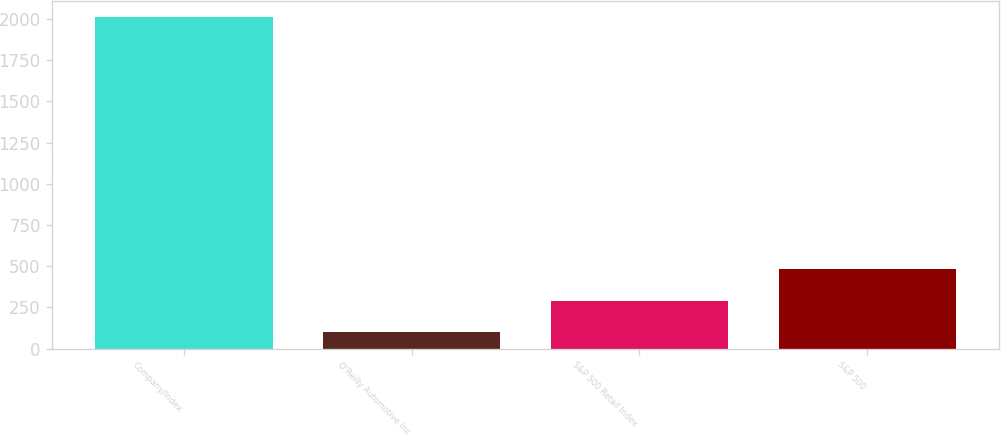<chart> <loc_0><loc_0><loc_500><loc_500><bar_chart><fcel>Company/Index<fcel>O'Reilly Automotive Inc<fcel>S&P 500 Retail Index<fcel>S&P 500<nl><fcel>2010<fcel>100<fcel>291<fcel>482<nl></chart> 